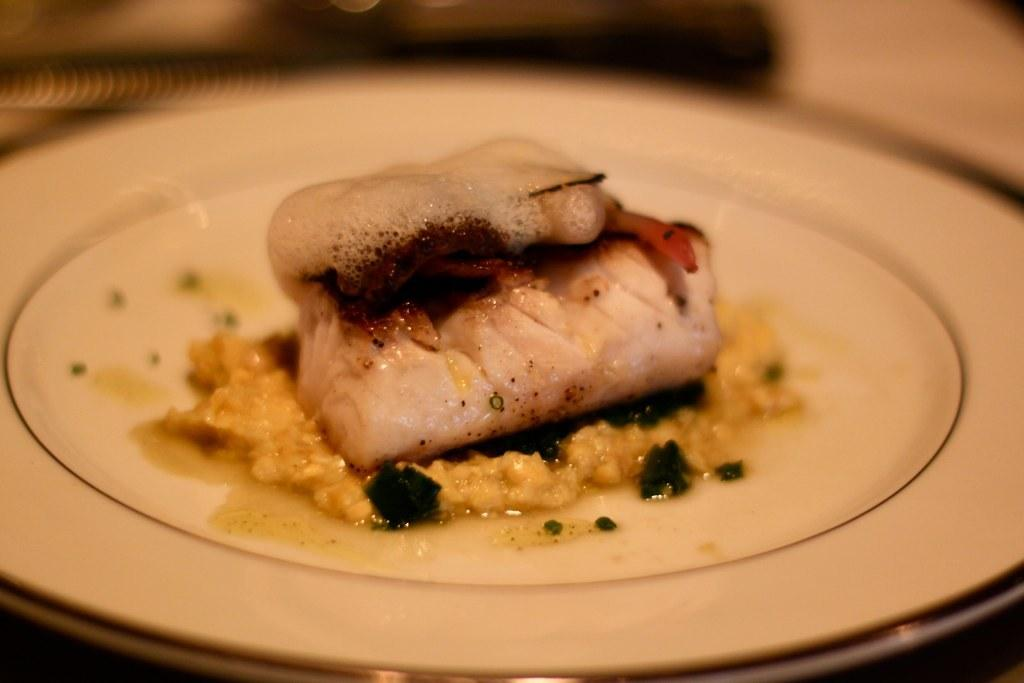What is the main subject of the image? There is a food item in the image. Can you describe the plate on which the food item is placed? The food item is on a white color plate. What type of verse can be seen written on the food item in the image? There is no verse written on the food item in the image. Where is the shelf located in the image? There is no shelf present in the image. 